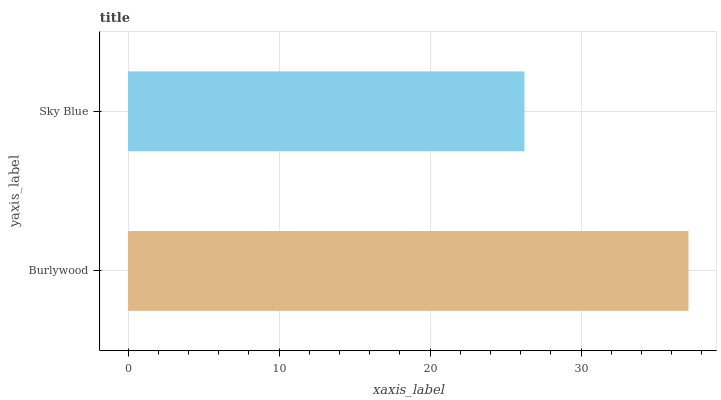Is Sky Blue the minimum?
Answer yes or no. Yes. Is Burlywood the maximum?
Answer yes or no. Yes. Is Sky Blue the maximum?
Answer yes or no. No. Is Burlywood greater than Sky Blue?
Answer yes or no. Yes. Is Sky Blue less than Burlywood?
Answer yes or no. Yes. Is Sky Blue greater than Burlywood?
Answer yes or no. No. Is Burlywood less than Sky Blue?
Answer yes or no. No. Is Burlywood the high median?
Answer yes or no. Yes. Is Sky Blue the low median?
Answer yes or no. Yes. Is Sky Blue the high median?
Answer yes or no. No. Is Burlywood the low median?
Answer yes or no. No. 